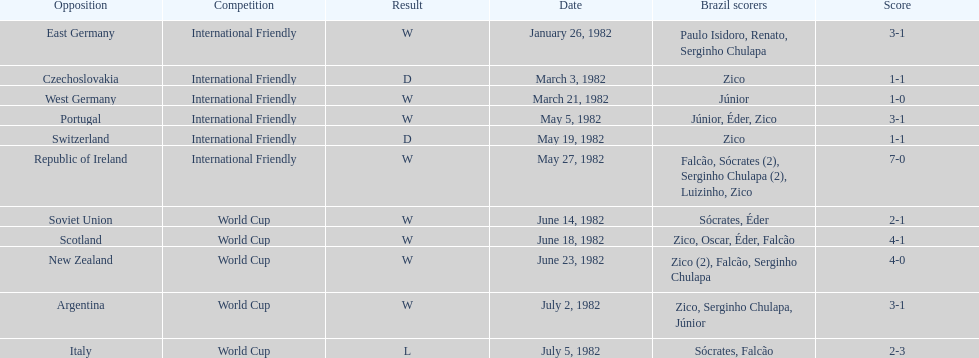Did brazil score more goals against the soviet union or portugal in 1982? Portugal. 